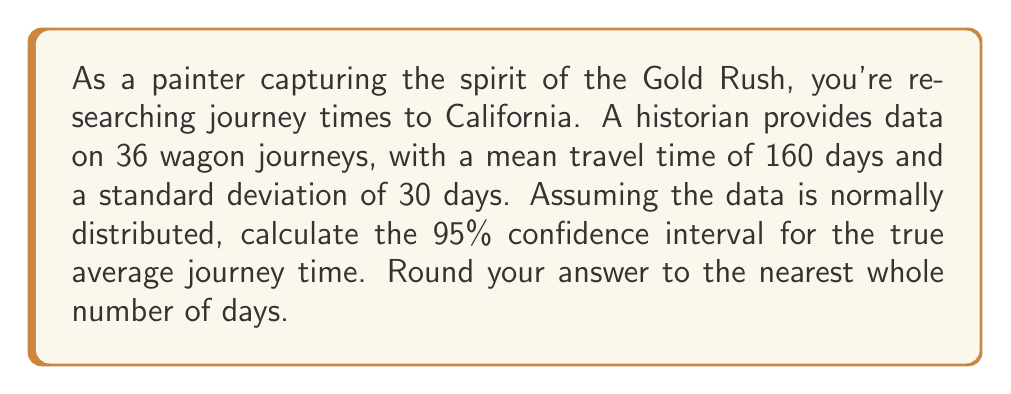Solve this math problem. To calculate the confidence interval, we'll follow these steps:

1) The formula for the confidence interval is:

   $$\bar{x} \pm t_{\alpha/2} \cdot \frac{s}{\sqrt{n}}$$

   where $\bar{x}$ is the sample mean, $s$ is the sample standard deviation, $n$ is the sample size, and $t_{\alpha/2}$ is the t-value for a 95% confidence interval.

2) We know:
   $\bar{x} = 160$ days
   $s = 30$ days
   $n = 36$

3) For a 95% confidence interval with 35 degrees of freedom (n-1), the t-value is approximately 2.030.

4) Plugging these values into our formula:

   $$160 \pm 2.030 \cdot \frac{30}{\sqrt{36}}$$

5) Simplify:
   $$160 \pm 2.030 \cdot \frac{30}{6} = 160 \pm 2.030 \cdot 5 = 160 \pm 10.15$$

6) Therefore, the 95% confidence interval is:
   $$(160 - 10.15, 160 + 10.15) = (149.85, 170.15)$$

7) Rounding to the nearest whole number:
   $$(150, 170)$$
Answer: (150, 170) days 